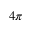<formula> <loc_0><loc_0><loc_500><loc_500>4 \pi</formula> 